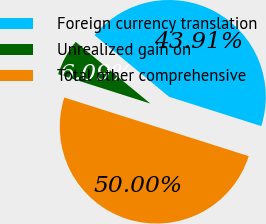Convert chart to OTSL. <chart><loc_0><loc_0><loc_500><loc_500><pie_chart><fcel>Foreign currency translation<fcel>Unrealized gain on<fcel>Total other comprehensive<nl><fcel>43.91%<fcel>6.09%<fcel>50.0%<nl></chart> 